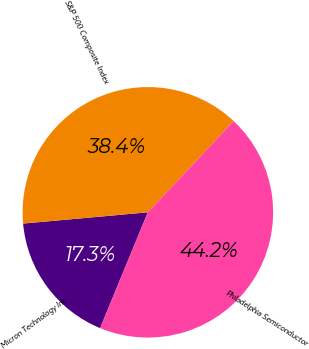<chart> <loc_0><loc_0><loc_500><loc_500><pie_chart><fcel>Micron Technology Inc<fcel>S&P 500 Composite Index<fcel>Philadelphia Semiconductor<nl><fcel>17.35%<fcel>38.44%<fcel>44.22%<nl></chart> 